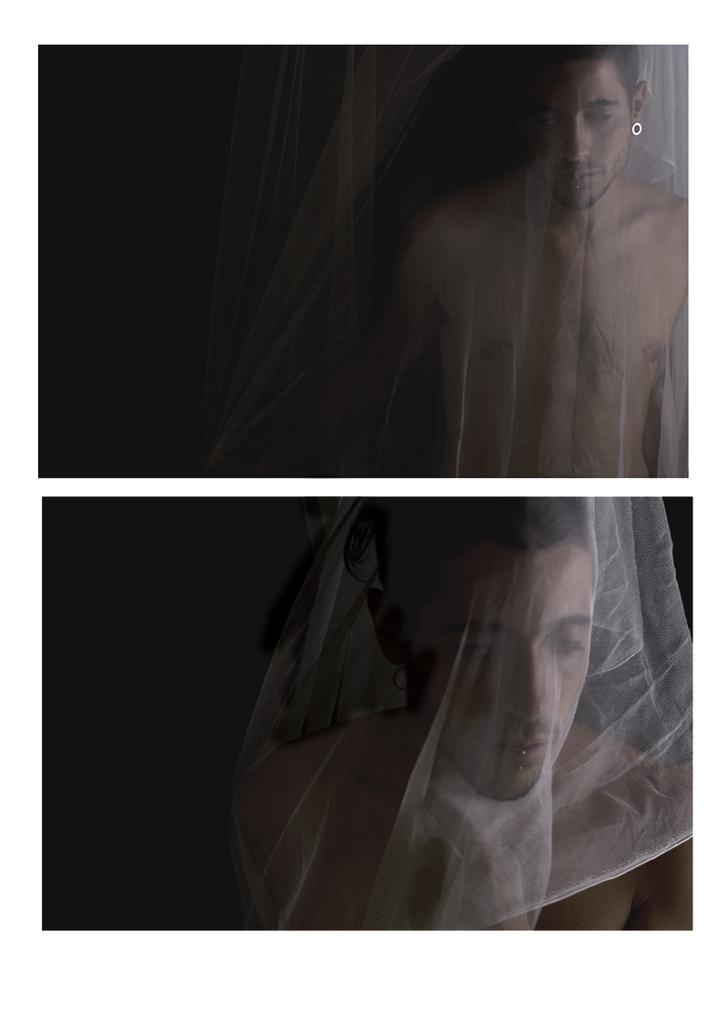What type of image is being described? The image is a collage. Can you describe any people in the image? There is a man in the image. What can be said about the background of the image? The background of the image is dark. What is the appearance of the white, transparent object on the man? It is a white, transparent object on the man. How many sisters does the man have in the image? There is no information about the man's sisters in the image. Is the man in the image serving a prison sentence? There is no indication of the man being in prison in the image. 